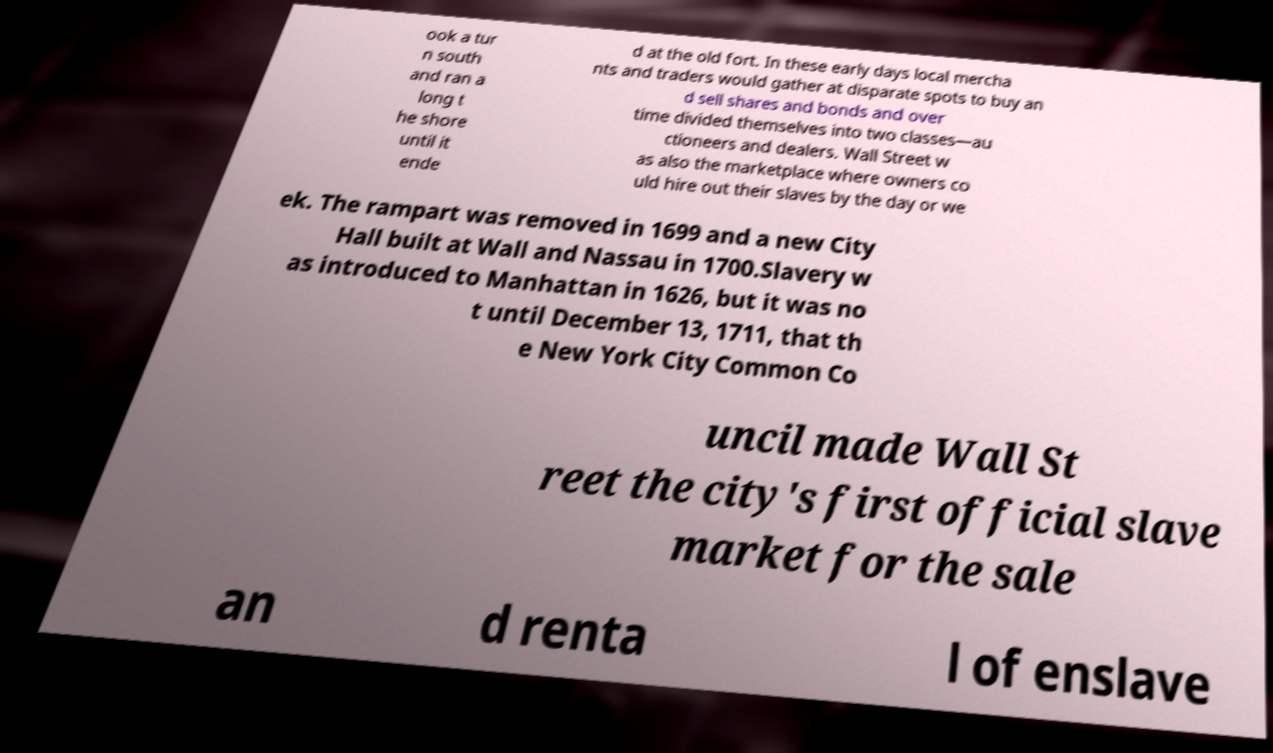Can you read and provide the text displayed in the image?This photo seems to have some interesting text. Can you extract and type it out for me? ook a tur n south and ran a long t he shore until it ende d at the old fort. In these early days local mercha nts and traders would gather at disparate spots to buy an d sell shares and bonds and over time divided themselves into two classes—au ctioneers and dealers. Wall Street w as also the marketplace where owners co uld hire out their slaves by the day or we ek. The rampart was removed in 1699 and a new City Hall built at Wall and Nassau in 1700.Slavery w as introduced to Manhattan in 1626, but it was no t until December 13, 1711, that th e New York City Common Co uncil made Wall St reet the city's first official slave market for the sale an d renta l of enslave 